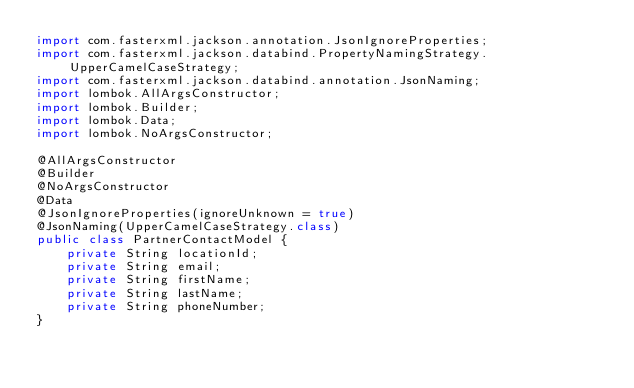<code> <loc_0><loc_0><loc_500><loc_500><_Java_>import com.fasterxml.jackson.annotation.JsonIgnoreProperties;
import com.fasterxml.jackson.databind.PropertyNamingStrategy.UpperCamelCaseStrategy;
import com.fasterxml.jackson.databind.annotation.JsonNaming;
import lombok.AllArgsConstructor;
import lombok.Builder;
import lombok.Data;
import lombok.NoArgsConstructor;

@AllArgsConstructor
@Builder
@NoArgsConstructor
@Data
@JsonIgnoreProperties(ignoreUnknown = true)
@JsonNaming(UpperCamelCaseStrategy.class)
public class PartnerContactModel {
    private String locationId;
    private String email;
    private String firstName;
    private String lastName;
    private String phoneNumber;
}
</code> 